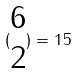<formula> <loc_0><loc_0><loc_500><loc_500>( \begin{matrix} 6 \\ 2 \end{matrix} ) = 1 5</formula> 